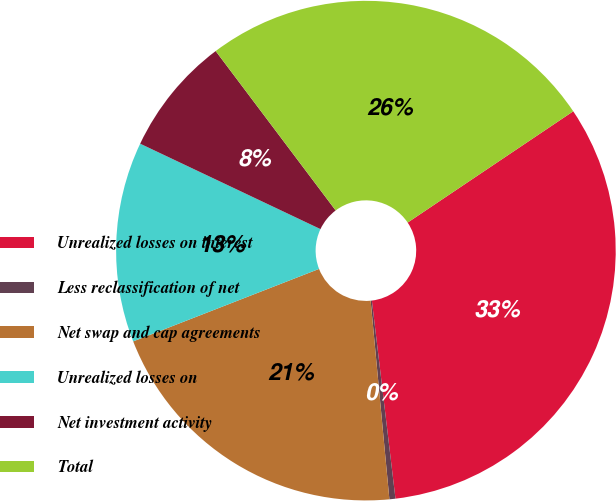Convert chart to OTSL. <chart><loc_0><loc_0><loc_500><loc_500><pie_chart><fcel>Unrealized losses on interest<fcel>Less reclassification of net<fcel>Net swap and cap agreements<fcel>Unrealized losses on<fcel>Net investment activity<fcel>Total<nl><fcel>32.53%<fcel>0.39%<fcel>20.58%<fcel>12.96%<fcel>7.69%<fcel>25.85%<nl></chart> 